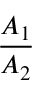Convert formula to latex. <formula><loc_0><loc_0><loc_500><loc_500>\frac { A _ { 1 } } { A _ { 2 } }</formula> 